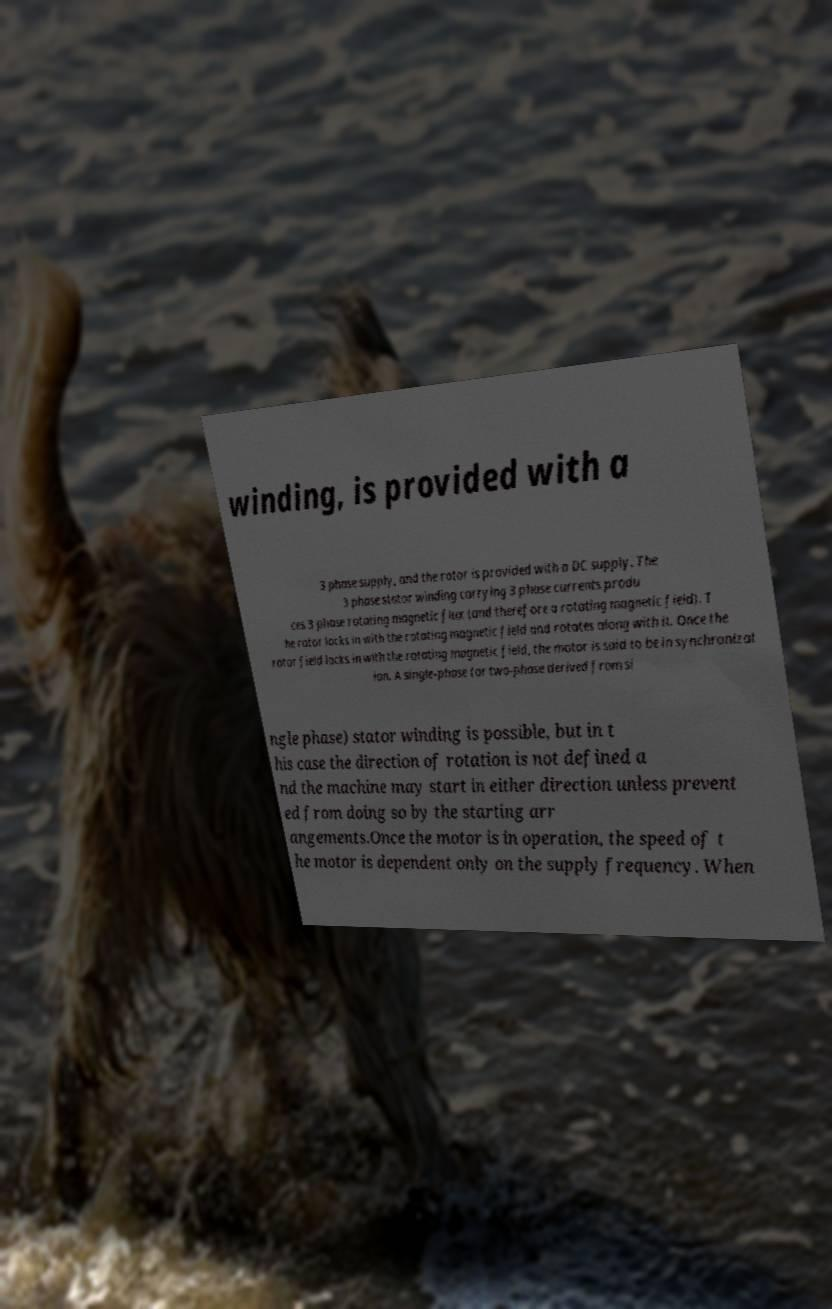For documentation purposes, I need the text within this image transcribed. Could you provide that? winding, is provided with a 3 phase supply, and the rotor is provided with a DC supply. The 3 phase stator winding carrying 3 phase currents produ ces 3 phase rotating magnetic flux (and therefore a rotating magnetic field). T he rotor locks in with the rotating magnetic field and rotates along with it. Once the rotor field locks in with the rotating magnetic field, the motor is said to be in synchronizat ion. A single-phase (or two-phase derived from si ngle phase) stator winding is possible, but in t his case the direction of rotation is not defined a nd the machine may start in either direction unless prevent ed from doing so by the starting arr angements.Once the motor is in operation, the speed of t he motor is dependent only on the supply frequency. When 